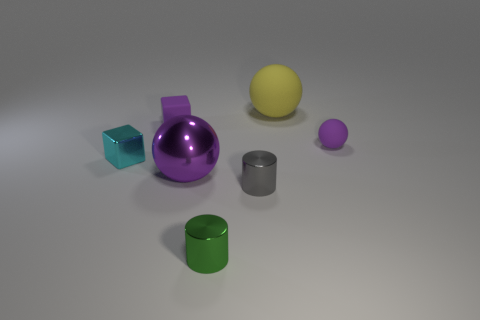Add 1 purple cylinders. How many objects exist? 8 Subtract all cylinders. How many objects are left? 5 Subtract all tiny cylinders. Subtract all rubber balls. How many objects are left? 3 Add 5 tiny purple rubber things. How many tiny purple rubber things are left? 7 Add 2 small purple matte blocks. How many small purple matte blocks exist? 3 Subtract 0 red cylinders. How many objects are left? 7 